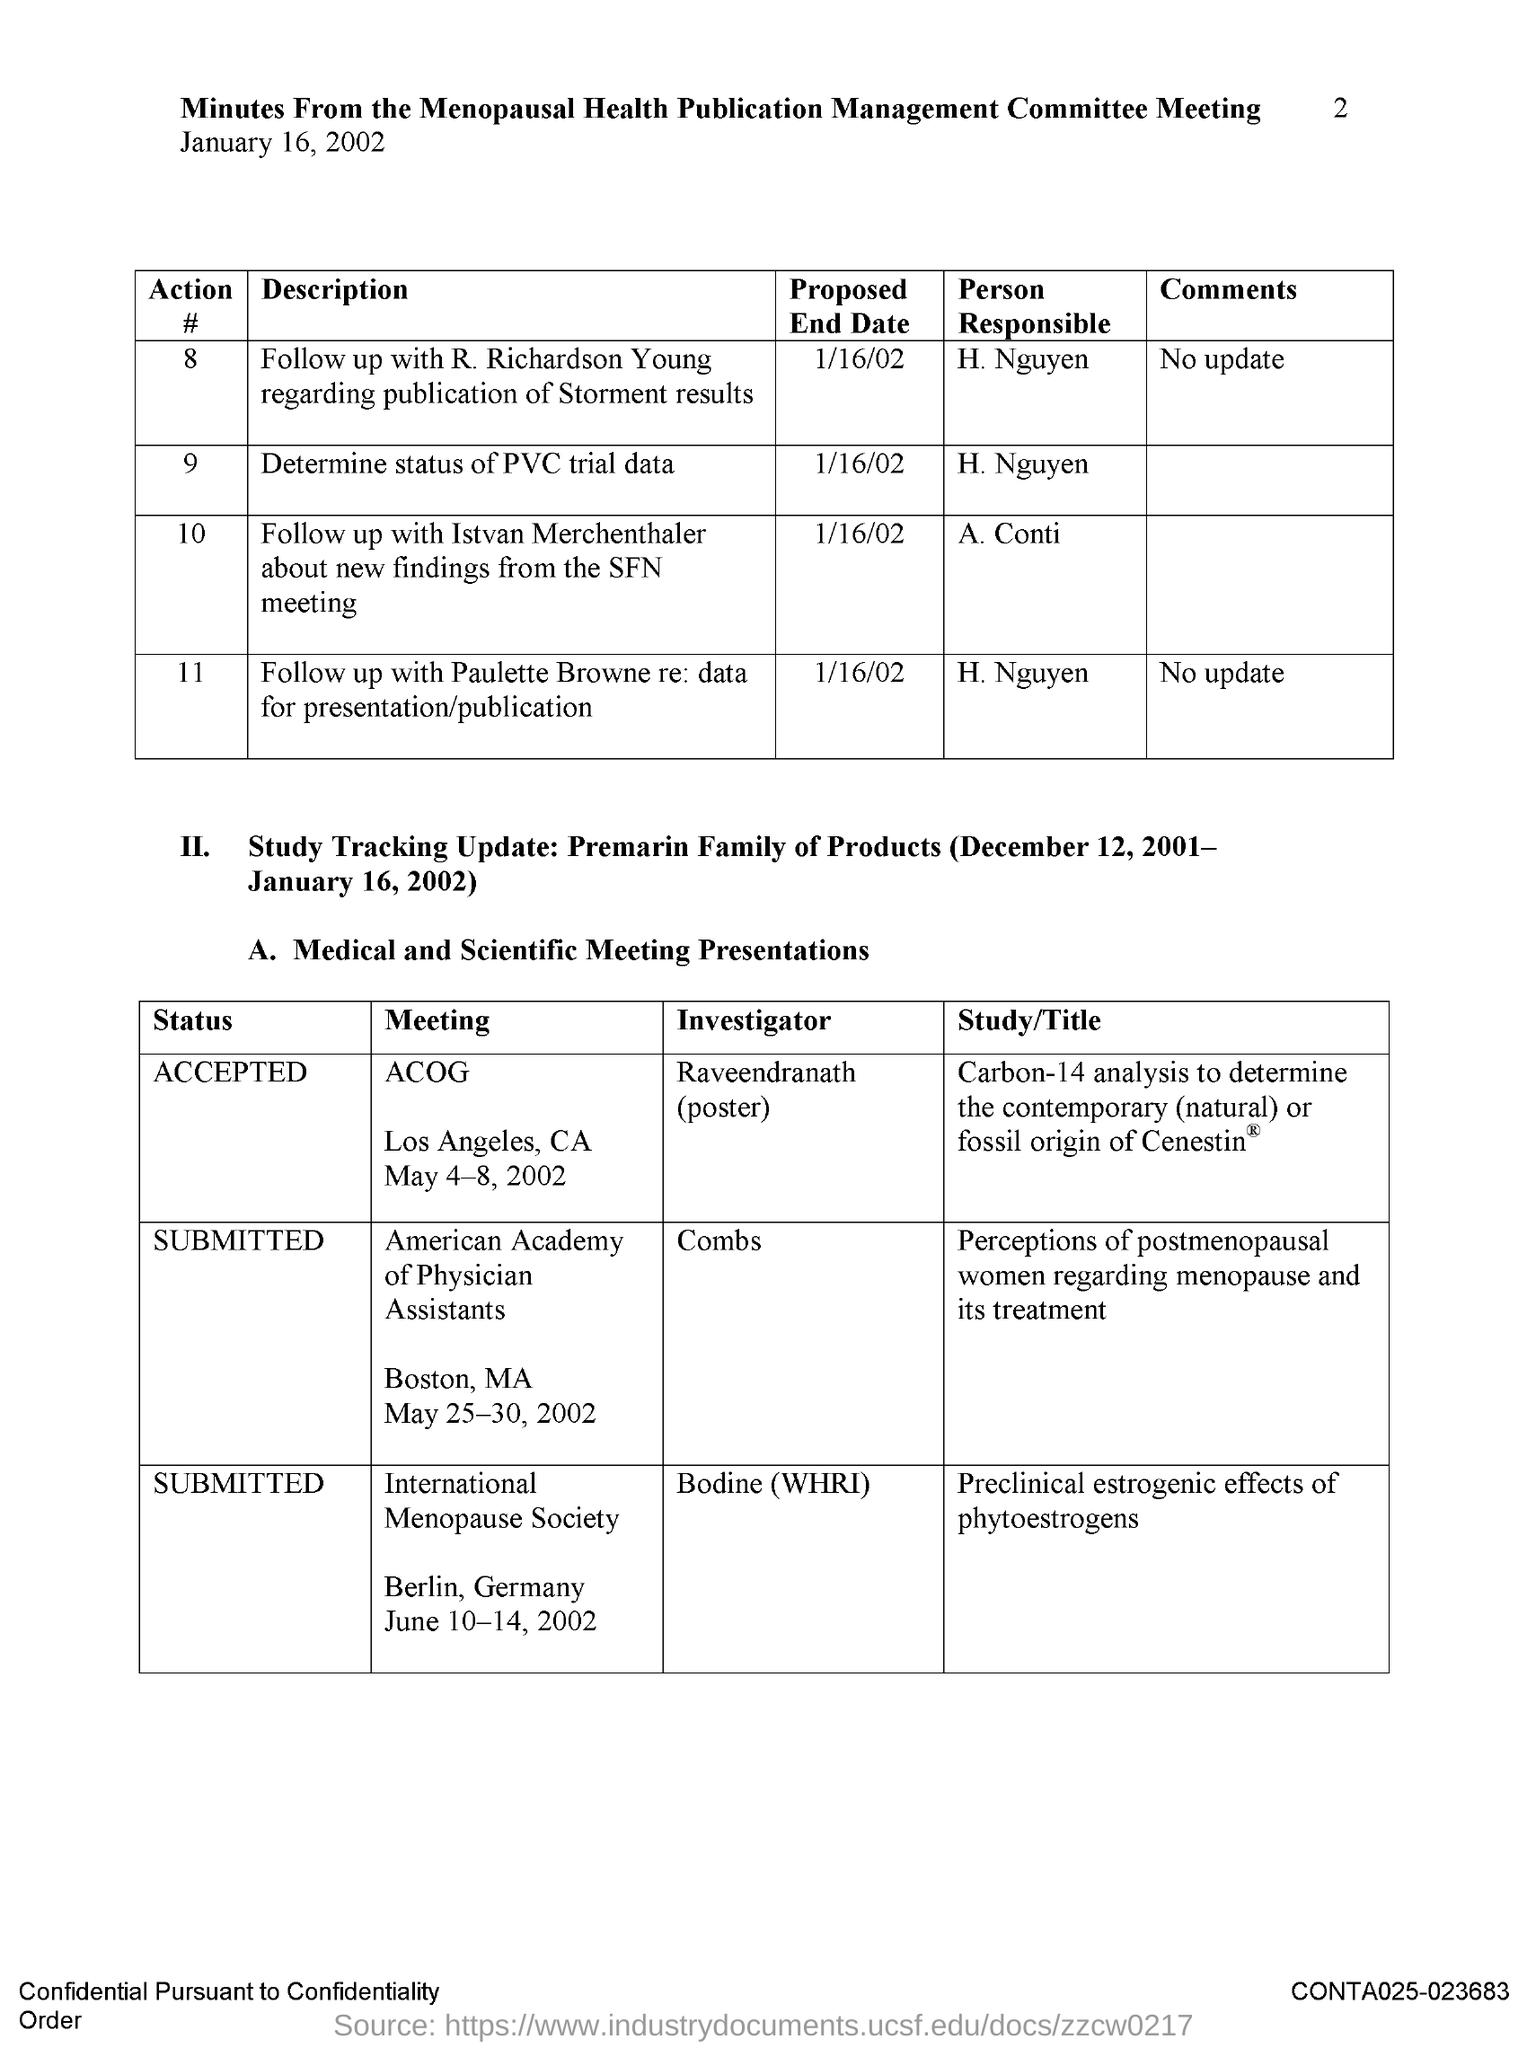Point out several critical features in this image. The Menopausal Health Publication Management Meeting will be held on January 16, 2002. The end date to determine the status of PVC trial data is January 16, 2002. The proposed end date to follow up with R. Richardson Young regarding the publication of the results of the study is January 16, 2002. The person responsible for determining the status of PVC trial data is H. Nguyen. 